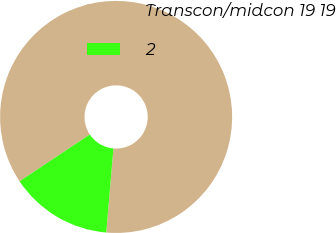Convert chart. <chart><loc_0><loc_0><loc_500><loc_500><pie_chart><fcel>Transcon/midcon 19 19<fcel>2<nl><fcel>85.71%<fcel>14.29%<nl></chart> 